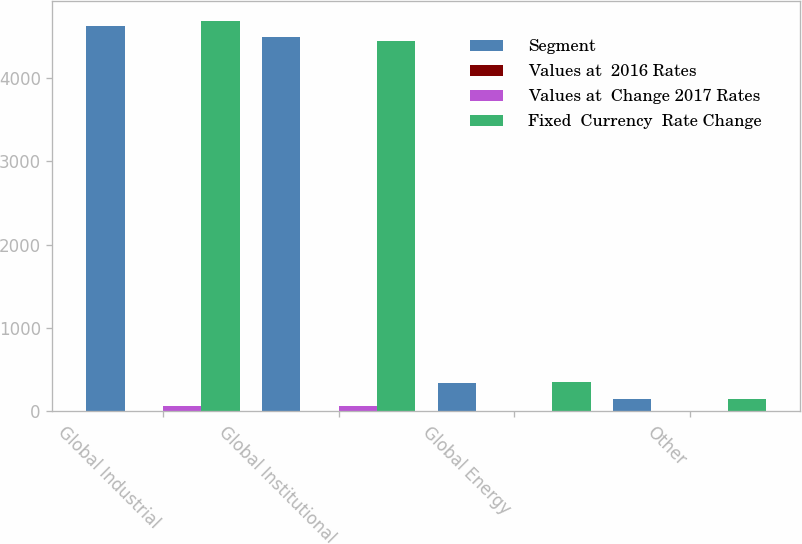<chart> <loc_0><loc_0><loc_500><loc_500><stacked_bar_chart><ecel><fcel>Global Industrial<fcel>Global Institutional<fcel>Global Energy<fcel>Other<nl><fcel>Segment<fcel>4617.1<fcel>4495.6<fcel>337.1<fcel>148.1<nl><fcel>Values at  2016 Rates<fcel>6.9<fcel>7.7<fcel>7.9<fcel>2.5<nl><fcel>Values at  Change 2017 Rates<fcel>63.2<fcel>63.2<fcel>1.7<fcel>0.4<nl><fcel>Fixed  Currency  Rate Change<fcel>4687.2<fcel>4440.1<fcel>346.7<fcel>145.2<nl></chart> 